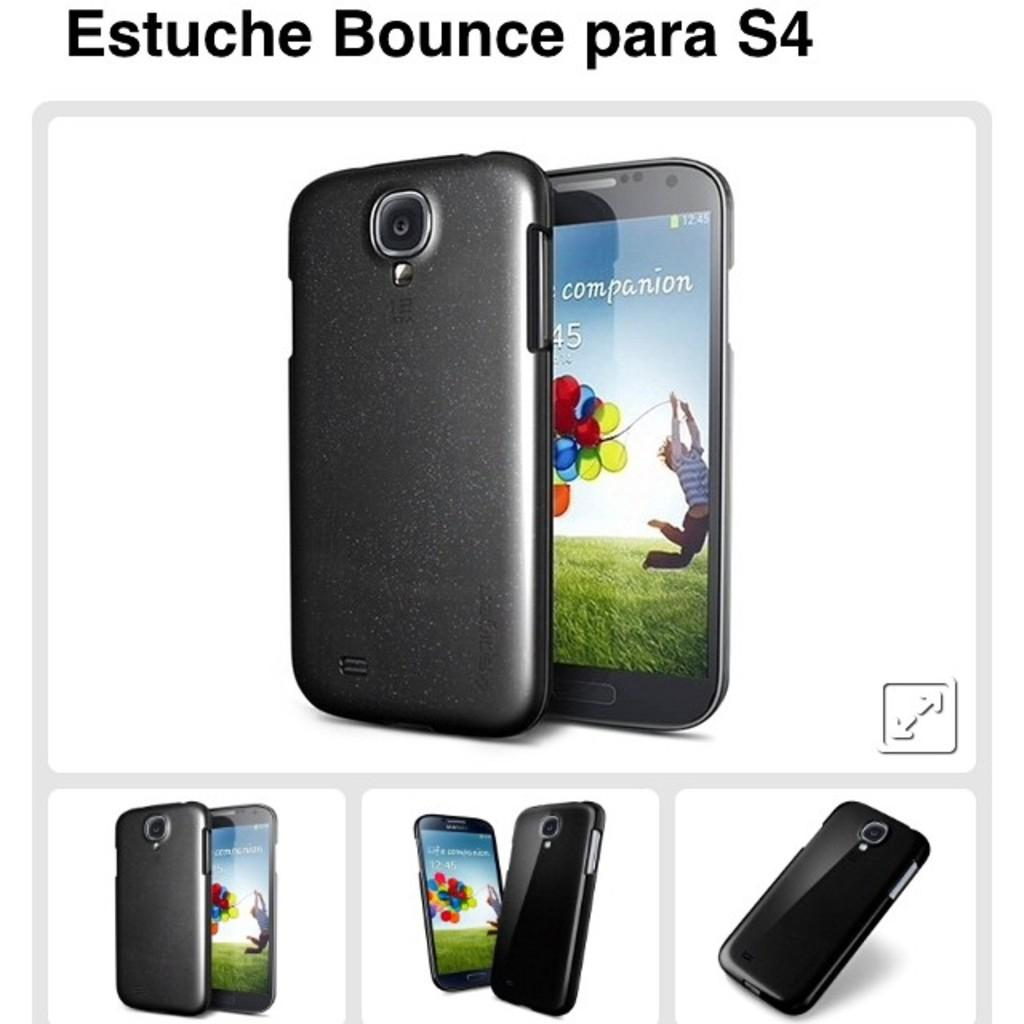<image>
Summarize the visual content of the image. A phone advertisement with "companion 45" on the display screen. 